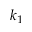Convert formula to latex. <formula><loc_0><loc_0><loc_500><loc_500>k _ { 1 }</formula> 